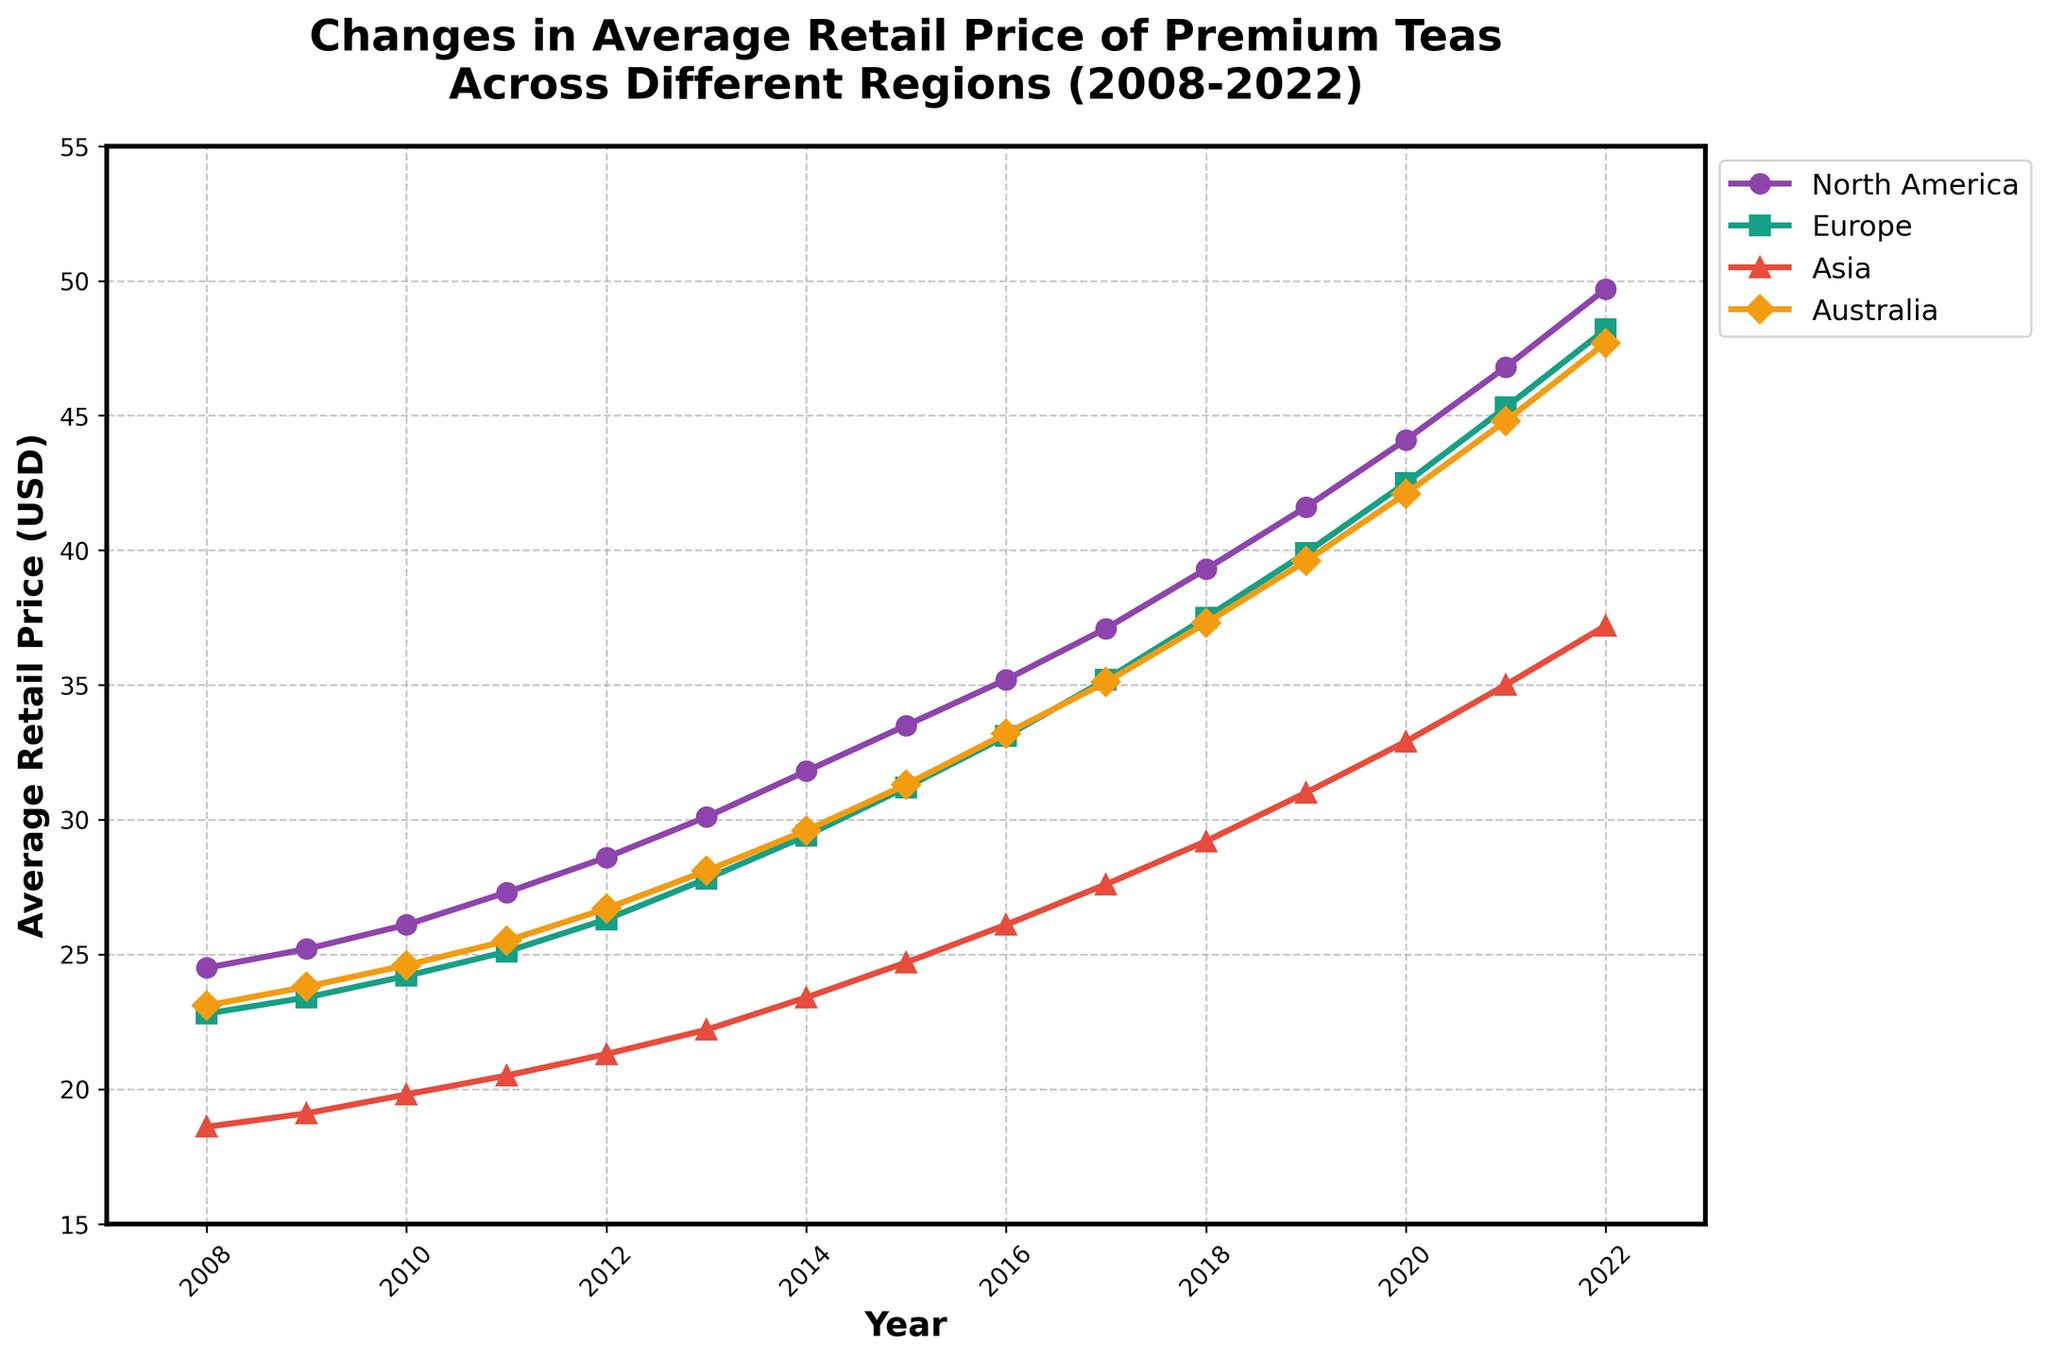What year did North America have the highest average retail price for premium teas? The line for North America (purple) shows its peak in 2022.
Answer: 2022 How does the average retail price in Asia compare in 2008 and 2022? In 2008, Asia had about 18.60 USD, and in 2022, it rose to approximately 37.20 USD, showing a significant increase.
Answer: Increased What is the difference in the average retail price of tea between North America and Europe in 2020? In 2020, North America had an average price of 44.10 USD, and Europe had 42.50 USD. The difference is 44.10 - 42.50 = 1.60 USD.
Answer: 1.60 USD Which region saw the steepest increase in the average retail price from 2008 to 2022? North America starts at 24.50 USD in 2008 and reaches 49.70 USD in 2022, showing the steepest increase compared to the other regions.
Answer: North America Between which consecutive years did Australia experience the most significant spike in average retail tea price? From the plot, the most significant spike for Australia (orange line) occurred between 2021 and 2022, where the price jumped notably.
Answer: 2021 to 2022 What was the average retail price of premium teas in Europe in 2015? Refer to the green line, and find the point corresponding to 2015. The value is around 31.20 USD.
Answer: 31.20 USD By how much did the average retail price of premium teas in North America increase from 2016 to 2019? In 2016, the price was 35.20 USD, and in 2019 it was 41.60 USD. The increase is 41.60 - 35.20 = 6.40 USD.
Answer: 6.40 USD Was the average retail price in Asia ever higher than in Australia during these years? Throughout the plot, the red line for Asia always remains below the orange line for Australia.
Answer: No What general trend is observable in the average retail prices of premium teas in all regions from 2008 to 2022? All lines trend upwards, indicating an increase in average retail prices over the years for all regions.
Answer: Upward trend 